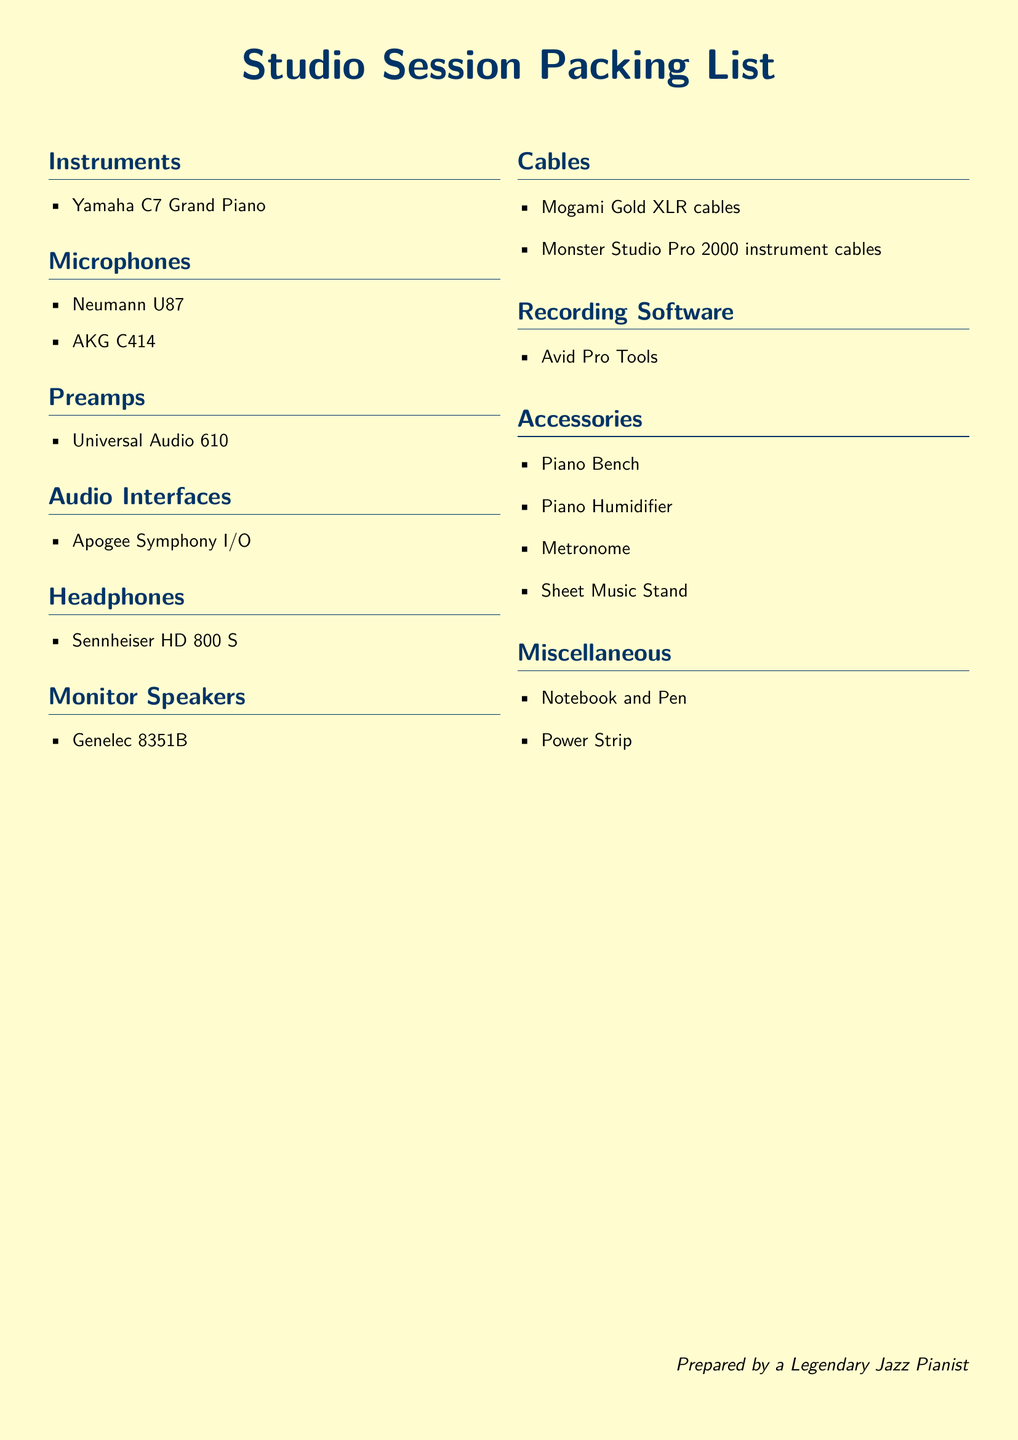What microphone is included in the packing list? The microphone section lists specific models, and the Neumann U87 is one of them.
Answer: Neumann U87 How many types of cables are mentioned? The cables section includes two different types, Mogami Gold XLR cables and Monster Studio Pro 2000 instrument cables.
Answer: Two What is the audio interface listed? The document specifies one audio interface, which is the Apogee Symphony I/O.
Answer: Apogee Symphony I/O How many accessories are included in the list? The accessories section contains four items, such as a Piano Bench and Metronome.
Answer: Four Which headphones are mentioned? The headphones section explicitly lists the Sennheiser HD 800 S.
Answer: Sennheiser HD 800 S Which preamp is included in the packing list? The document mentions one specific preamp, which is the Universal Audio 610.
Answer: Universal Audio 610 What type of piano is featured in the document? The instruments section lists the Yamaha C7 Grand Piano specifically.
Answer: Yamaha C7 Grand Piano Is there a recording software mentioned in the list? The document includes a specific recording software, Avid Pro Tools, in its designated section.
Answer: Avid Pro Tools What is the purpose of the Power Strip mentioned in the miscellaneous section? The Power Strip is categorized under miscellaneous items, implying it's used for electrical needs during the studio session.
Answer: Electrical needs 